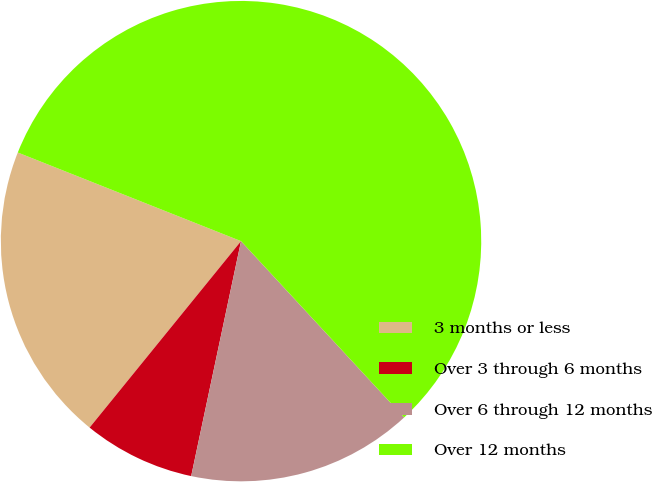Convert chart. <chart><loc_0><loc_0><loc_500><loc_500><pie_chart><fcel>3 months or less<fcel>Over 3 through 6 months<fcel>Over 6 through 12 months<fcel>Over 12 months<nl><fcel>20.16%<fcel>7.53%<fcel>15.21%<fcel>57.11%<nl></chart> 